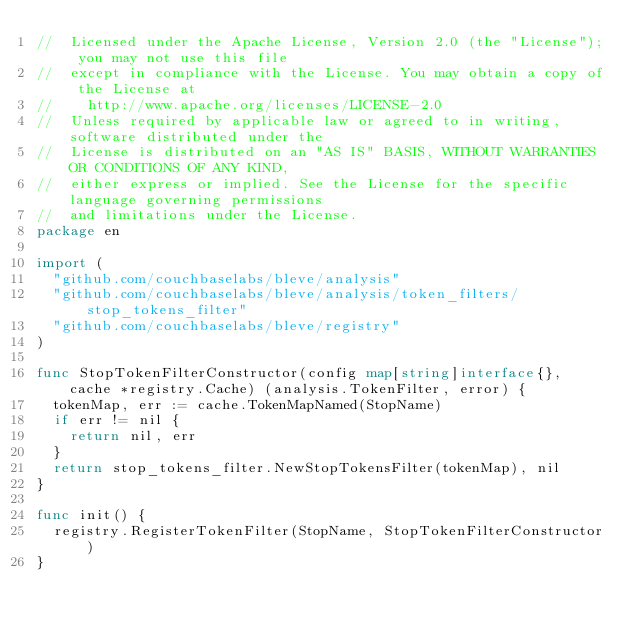<code> <loc_0><loc_0><loc_500><loc_500><_Go_>//  Licensed under the Apache License, Version 2.0 (the "License"); you may not use this file
//  except in compliance with the License. You may obtain a copy of the License at
//    http://www.apache.org/licenses/LICENSE-2.0
//  Unless required by applicable law or agreed to in writing, software distributed under the
//  License is distributed on an "AS IS" BASIS, WITHOUT WARRANTIES OR CONDITIONS OF ANY KIND,
//  either express or implied. See the License for the specific language governing permissions
//  and limitations under the License.
package en

import (
	"github.com/couchbaselabs/bleve/analysis"
	"github.com/couchbaselabs/bleve/analysis/token_filters/stop_tokens_filter"
	"github.com/couchbaselabs/bleve/registry"
)

func StopTokenFilterConstructor(config map[string]interface{}, cache *registry.Cache) (analysis.TokenFilter, error) {
	tokenMap, err := cache.TokenMapNamed(StopName)
	if err != nil {
		return nil, err
	}
	return stop_tokens_filter.NewStopTokensFilter(tokenMap), nil
}

func init() {
	registry.RegisterTokenFilter(StopName, StopTokenFilterConstructor)
}
</code> 